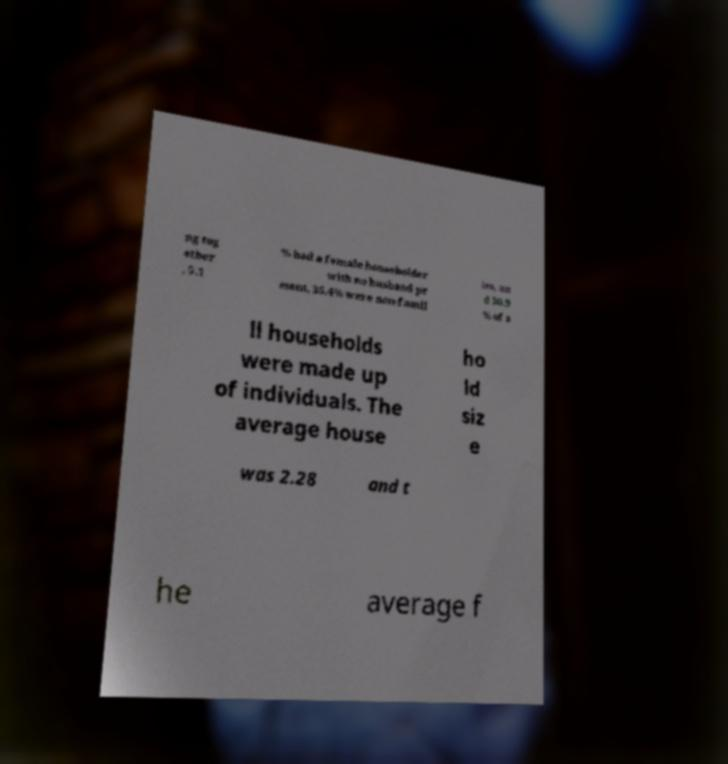I need the written content from this picture converted into text. Can you do that? ng tog ether , 5.1 % had a female householder with no husband pr esent, 35.4% were non-famil ies, an d 30.9 % of a ll households were made up of individuals. The average house ho ld siz e was 2.28 and t he average f 